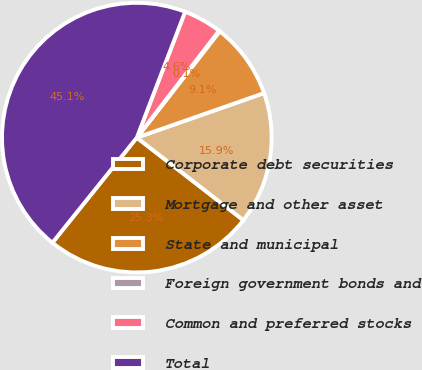<chart> <loc_0><loc_0><loc_500><loc_500><pie_chart><fcel>Corporate debt securities<fcel>Mortgage and other asset<fcel>State and municipal<fcel>Foreign government bonds and<fcel>Common and preferred stocks<fcel>Total<nl><fcel>25.28%<fcel>15.85%<fcel>9.1%<fcel>0.11%<fcel>4.6%<fcel>45.06%<nl></chart> 